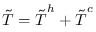<formula> <loc_0><loc_0><loc_500><loc_500>\tilde { T } = \tilde { T } ^ { h } + \tilde { T } ^ { c }</formula> 